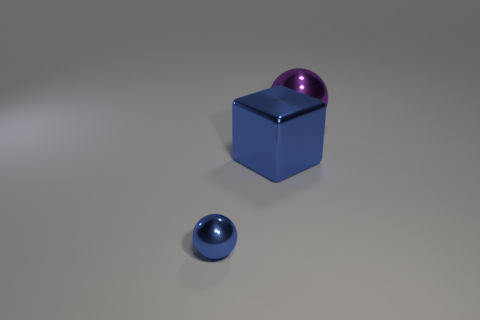Can you describe the lighting and shadows in the scene? The lighting in the image seems to come from above, casting soft shadows downward from the objects onto the surface. The shadows are consistent with a single light source, possibly diffused, creating a serene and clean atmosphere in the scene. 